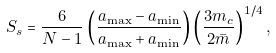<formula> <loc_0><loc_0><loc_500><loc_500>S _ { s } = \frac { 6 } { N - 1 } \left ( \frac { a _ { \max } - a _ { \min } } { a _ { \max } + a _ { \min } } \right ) \left ( \frac { 3 m _ { c } } { 2 \bar { m } } \right ) ^ { 1 / 4 } ,</formula> 